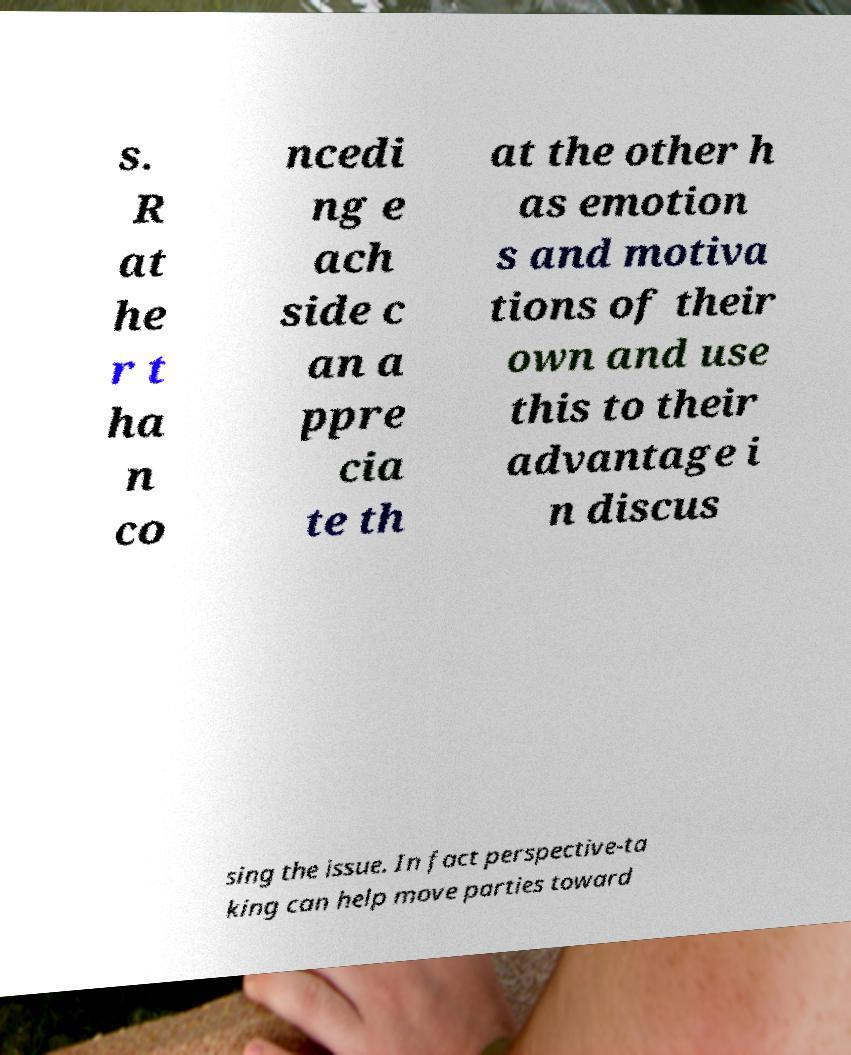Could you extract and type out the text from this image? s. R at he r t ha n co ncedi ng e ach side c an a ppre cia te th at the other h as emotion s and motiva tions of their own and use this to their advantage i n discus sing the issue. In fact perspective-ta king can help move parties toward 